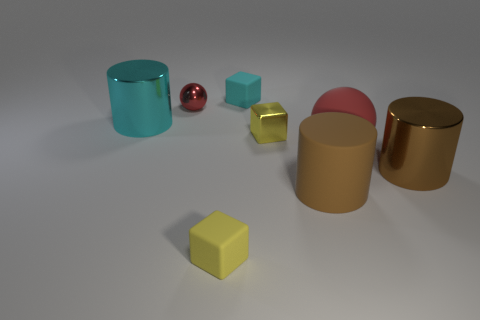The big rubber thing that is the same shape as the brown metallic object is what color?
Your response must be concise. Brown. What number of things are behind the small yellow metal thing and to the right of the tiny red ball?
Ensure brevity in your answer.  1. Are there more small yellow metal objects right of the large cyan object than brown shiny cylinders that are in front of the big brown metallic cylinder?
Keep it short and to the point. Yes. What size is the brown metallic object?
Your answer should be compact. Large. Is there a big brown metallic thing that has the same shape as the small red metal object?
Provide a succinct answer. No. Does the tiny yellow rubber object have the same shape as the small yellow thing that is behind the brown matte object?
Provide a succinct answer. Yes. How big is the thing that is both on the left side of the small cyan rubber thing and in front of the tiny yellow shiny object?
Give a very brief answer. Small. What number of yellow metal objects are there?
Ensure brevity in your answer.  1. What is the material of the yellow thing that is the same size as the metallic block?
Your answer should be compact. Rubber. Is there a matte sphere that has the same size as the yellow metal block?
Provide a succinct answer. No. 